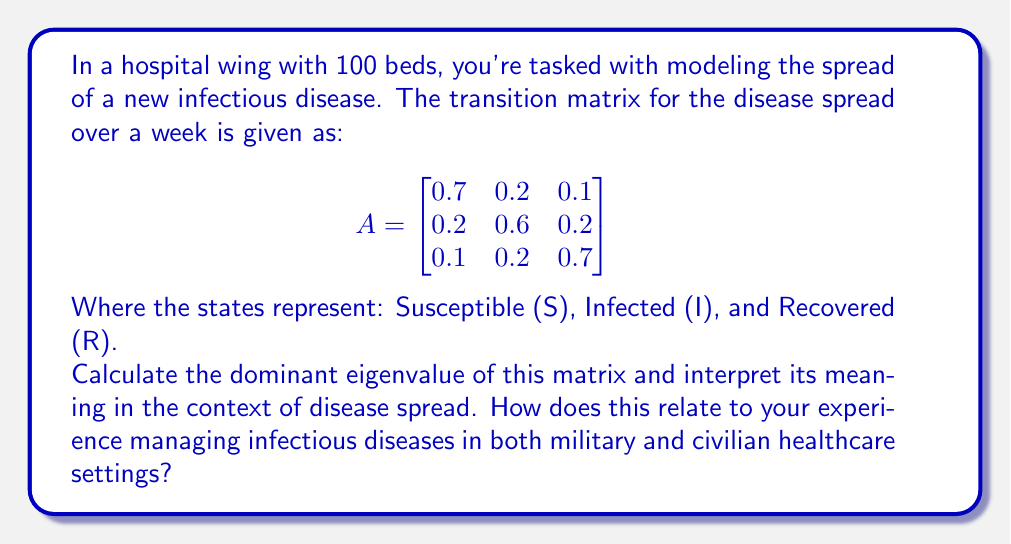Can you solve this math problem? To solve this problem, we need to follow these steps:

1) Find the characteristic equation of the matrix A:
   $$det(A - \lambda I) = 0$$

2) Solve the characteristic equation to find the eigenvalues.

3) Identify the dominant eigenvalue (the one with the largest absolute value).

4) Interpret the result in the context of disease spread.

Step 1: Finding the characteristic equation

$$det(A - \lambda I) = \begin{vmatrix}
0.7-\lambda & 0.2 & 0.1 \\
0.2 & 0.6-\lambda & 0.2 \\
0.1 & 0.2 & 0.7-\lambda
\end{vmatrix} = 0$$

Step 2: Solving the characteristic equation

Expanding the determinant:

$$(0.7-\lambda)((0.6-\lambda)(0.7-\lambda)-0.04) - 0.2(0.2(0.7-\lambda)-0.02) + 0.1(0.04-0.2(0.6-\lambda)) = 0$$

Simplifying:

$$-\lambda^3 + 2\lambda^2 - 1.3\lambda + 0.28 = 0$$

The roots of this equation are the eigenvalues. Using a calculator or computer algebra system, we find:

$$\lambda_1 \approx 1, \lambda_2 \approx 0.5, \lambda_3 \approx 0.5$$

Step 3: Identifying the dominant eigenvalue

The dominant eigenvalue is $\lambda_1 = 1$.

Step 4: Interpretation

In the context of disease spread, the dominant eigenvalue being 1 indicates that the disease is at a critical threshold. This means:

1) The disease is neither growing exponentially nor dying out over time.
2) Each infected person, on average, infects exactly one other person before recovering.
3) The overall proportion of people in each state (S, I, R) will remain roughly constant over time.

This situation requires careful monitoring and intervention to prevent the disease from tipping into exponential growth. As an experienced nurse with both military and civilian background, you would recognize this as a crucial point where proper infection control measures can make a significant difference in preventing an outbreak.
Answer: The dominant eigenvalue is 1, indicating a critical threshold where the disease spread is stable but requires careful management to prevent potential outbreaks. 